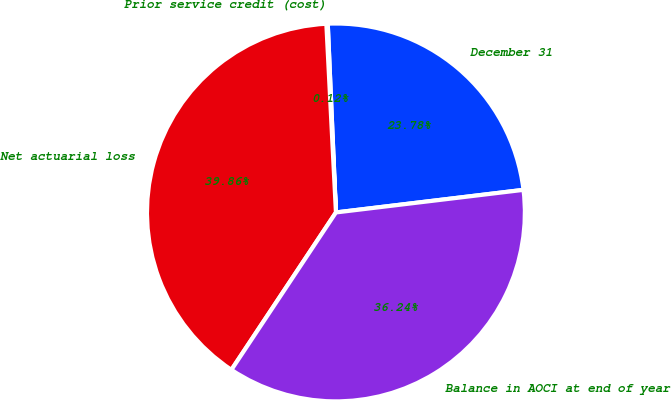<chart> <loc_0><loc_0><loc_500><loc_500><pie_chart><fcel>December 31<fcel>Prior service credit (cost)<fcel>Net actuarial loss<fcel>Balance in AOCI at end of year<nl><fcel>23.78%<fcel>0.12%<fcel>39.86%<fcel>36.24%<nl></chart> 